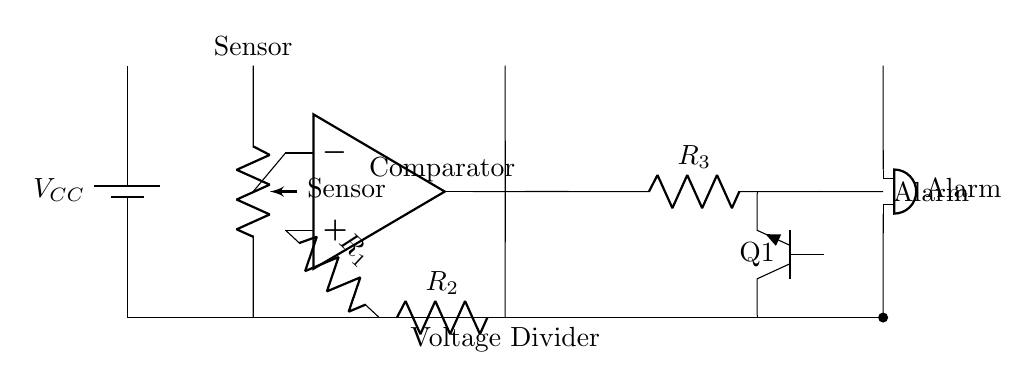What type of sensor is used in this circuit? The circuit diagram shows a PIR sensor, which is typically used for motion detection. It is represented at the top left of the diagram.
Answer: PIR sensor What does the op-amp act as in this circuit? The op-amp in this circuit acts as a comparator, which compares the voltage from the sensor with a reference voltage set by resistors. This is indicated by the connector labeled with the op-amp symbol.
Answer: Comparator What is the role of the resistors R1, R2, and R3? Resistors R1 and R2 form a voltage divider that sets the reference voltage for the comparator, while R3 controls the current flowing to the transistor Q1 to activate the alarm.
Answer: Voltage divider and current control How does the alarm get activated in this circuit? The alarm is activated when the output from the comparator changes state, which happens when the sensor detects motion. This output signal drives the transistor Q1, which in turn connects the alarm to the power supply.
Answer: Through the transistor Q1 What is the purpose of the voltage divider in this circuit? The voltage divider, created by resistors R1 and R2, provides a reference voltage to the non-inverting input of the op-amp to determine when to trigger the alarm based on sensor output.
Answer: Provide reference voltage What component connects the sensor output to the comparator? The sensor output connects directly to the inverting input of the op-amp, allowing the comparator to assess whether the sensor voltage exceeds the reference voltage.
Answer: Op-amp input What type of alarm is depicted in this circuit? The circuit shows a buzzer as the alarm component, which produces sound when activated by the output from the transistor Q1.
Answer: Buzzer 